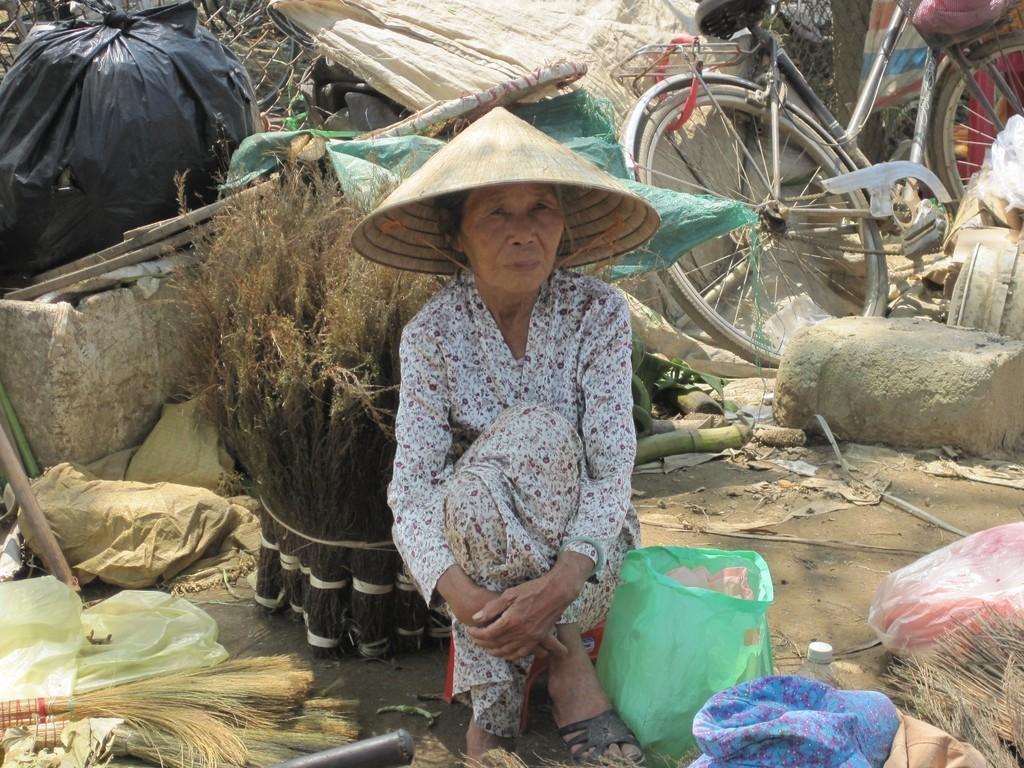Describe this image in one or two sentences. In the image there is an old woman with hat over her head sitting on land with a cover in front of her and broomsticks behind her and there are many things on the land, on the right side there is a cycle in front of rocks, on the left side it seems to be a garbage. 